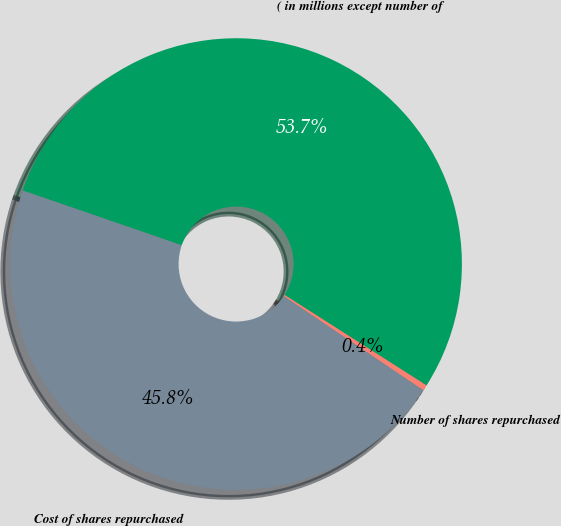Convert chart to OTSL. <chart><loc_0><loc_0><loc_500><loc_500><pie_chart><fcel>( in millions except number of<fcel>Number of shares repurchased<fcel>Cost of shares repurchased<nl><fcel>53.74%<fcel>0.42%<fcel>45.83%<nl></chart> 